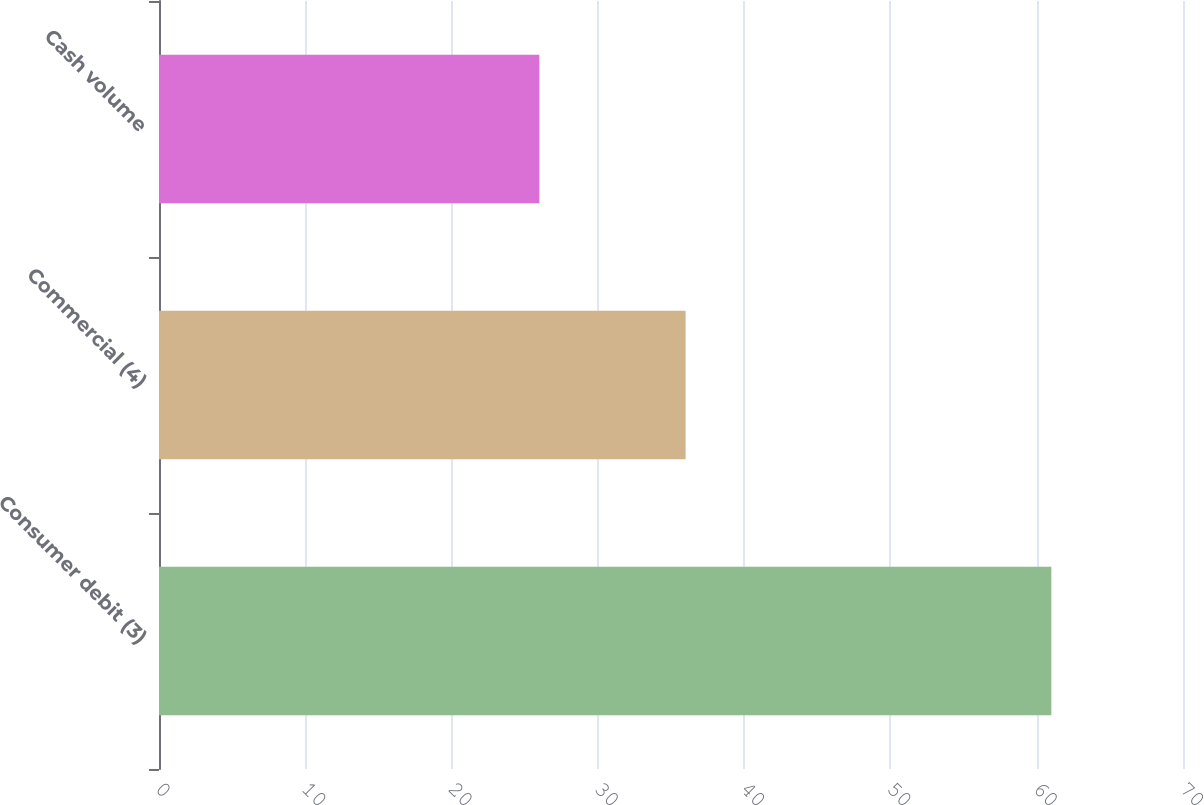Convert chart to OTSL. <chart><loc_0><loc_0><loc_500><loc_500><bar_chart><fcel>Consumer debit (3)<fcel>Commercial (4)<fcel>Cash volume<nl><fcel>61<fcel>36<fcel>26<nl></chart> 